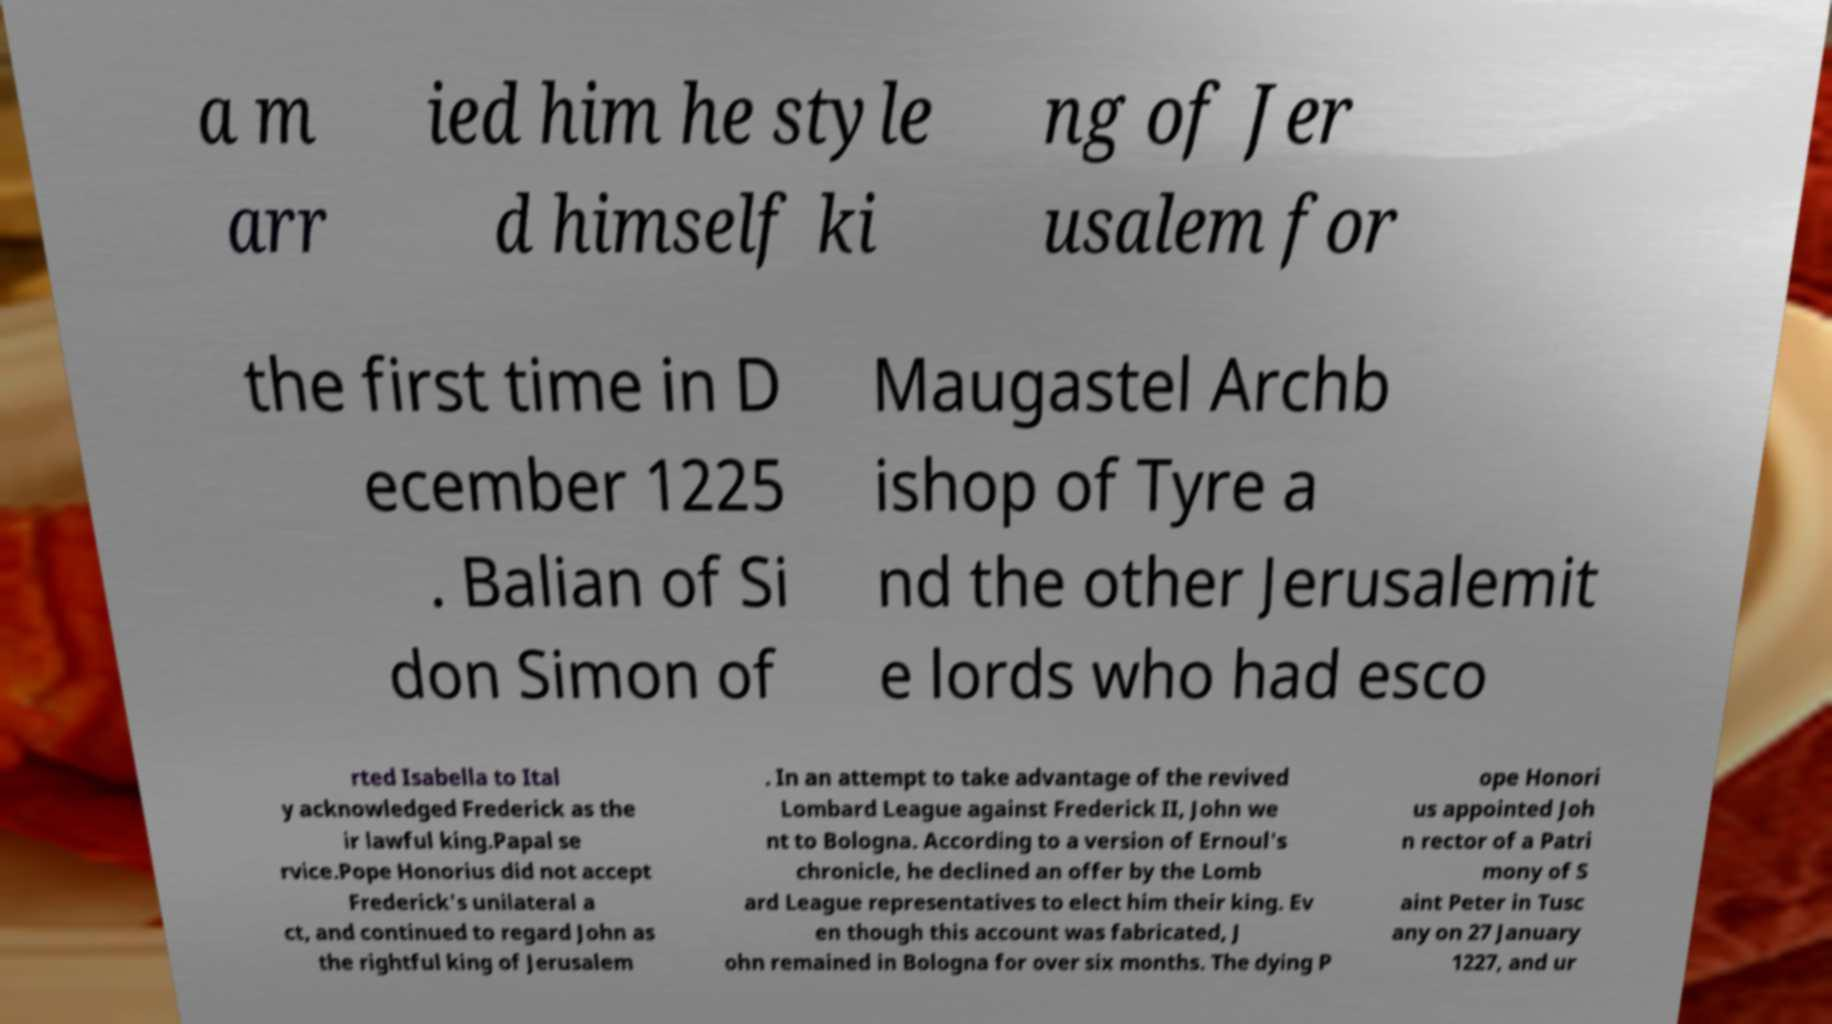What messages or text are displayed in this image? I need them in a readable, typed format. a m arr ied him he style d himself ki ng of Jer usalem for the first time in D ecember 1225 . Balian of Si don Simon of Maugastel Archb ishop of Tyre a nd the other Jerusalemit e lords who had esco rted Isabella to Ital y acknowledged Frederick as the ir lawful king.Papal se rvice.Pope Honorius did not accept Frederick's unilateral a ct, and continued to regard John as the rightful king of Jerusalem . In an attempt to take advantage of the revived Lombard League against Frederick II, John we nt to Bologna. According to a version of Ernoul's chronicle, he declined an offer by the Lomb ard League representatives to elect him their king. Ev en though this account was fabricated, J ohn remained in Bologna for over six months. The dying P ope Honori us appointed Joh n rector of a Patri mony of S aint Peter in Tusc any on 27 January 1227, and ur 